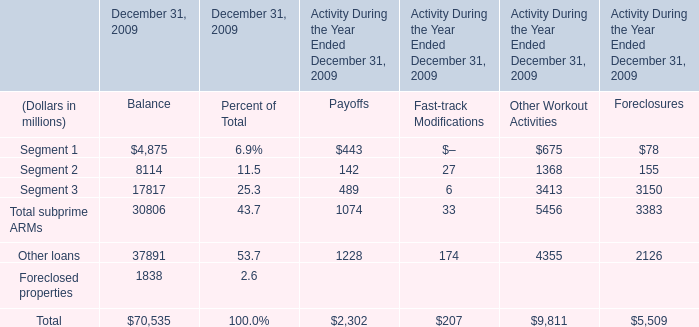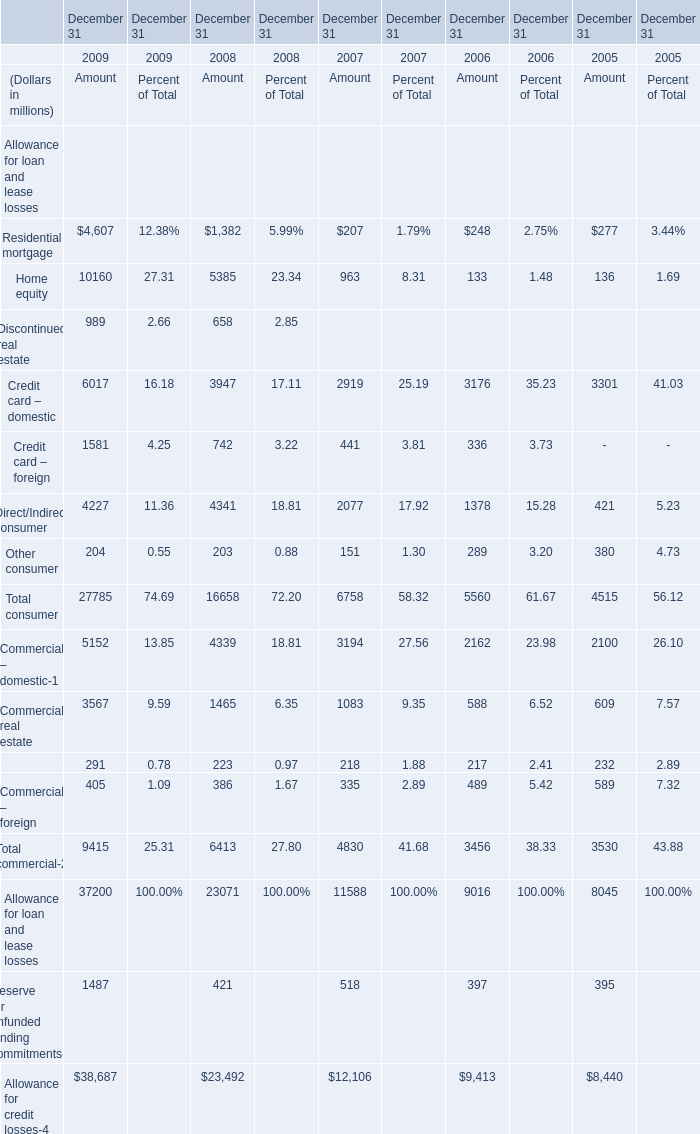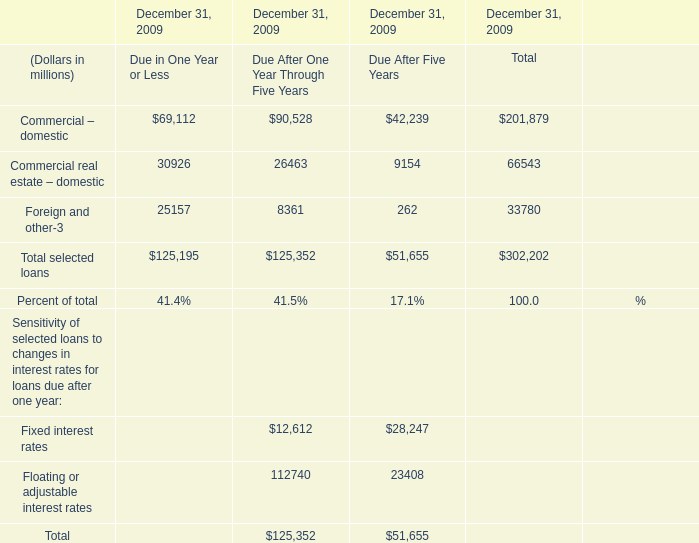What's the sum of the Fixed interest rates in the years where Fixed interest rates is greater than 20000? (in million) 
Computations: (12612 + 28247)
Answer: 40859.0. 